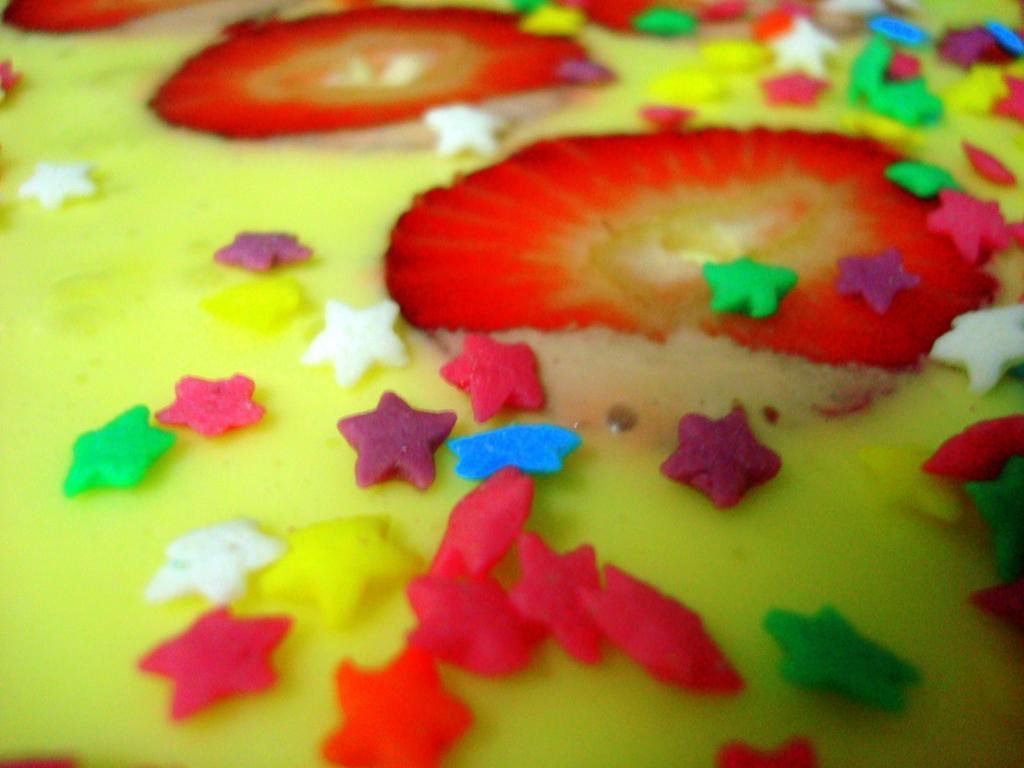In one or two sentences, can you explain what this image depicts? In this image, we can see food with colorful toppings. 